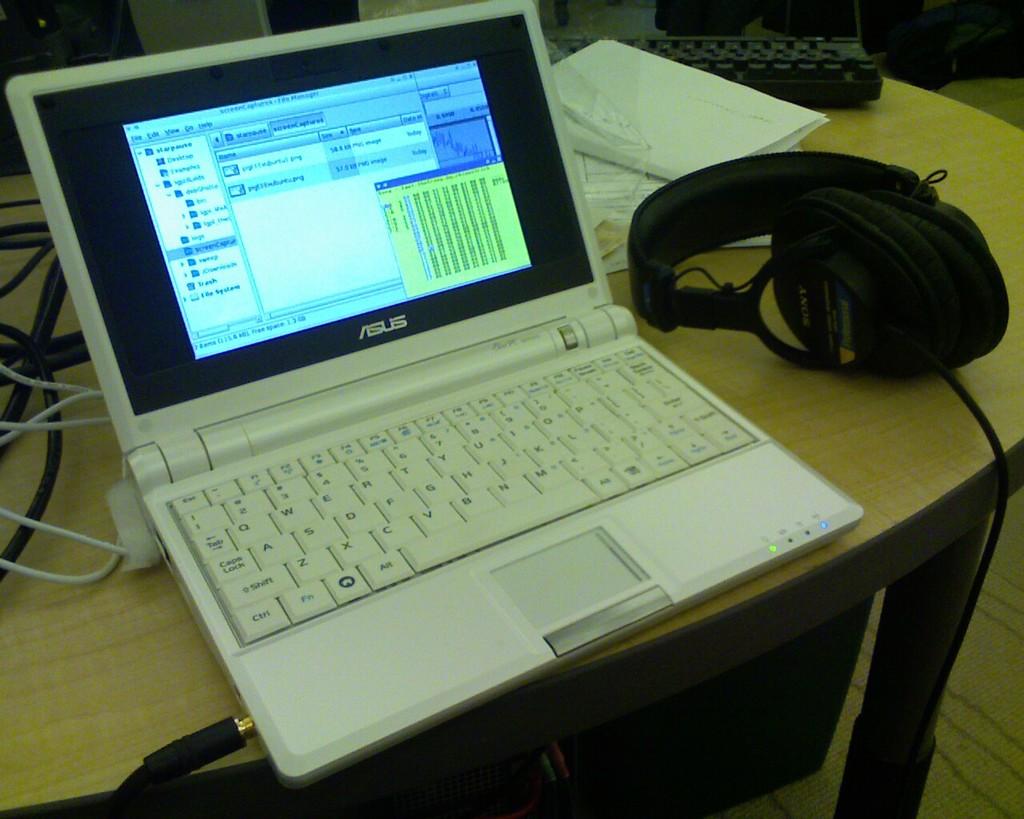What brand of laptop is this?
Make the answer very short. Asus. What is the brand of headphones?
Your response must be concise. Sony. 